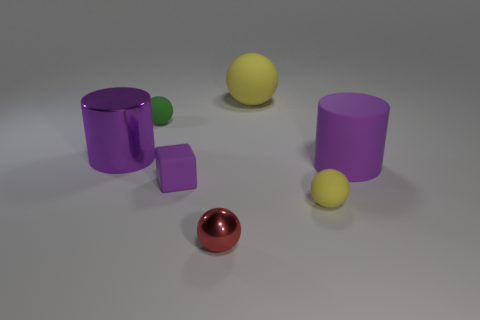Add 2 large yellow balls. How many objects exist? 9 Subtract all spheres. How many objects are left? 3 Subtract 0 blue cubes. How many objects are left? 7 Subtract all big yellow shiny things. Subtract all red objects. How many objects are left? 6 Add 1 tiny yellow spheres. How many tiny yellow spheres are left? 2 Add 4 gray shiny blocks. How many gray shiny blocks exist? 4 